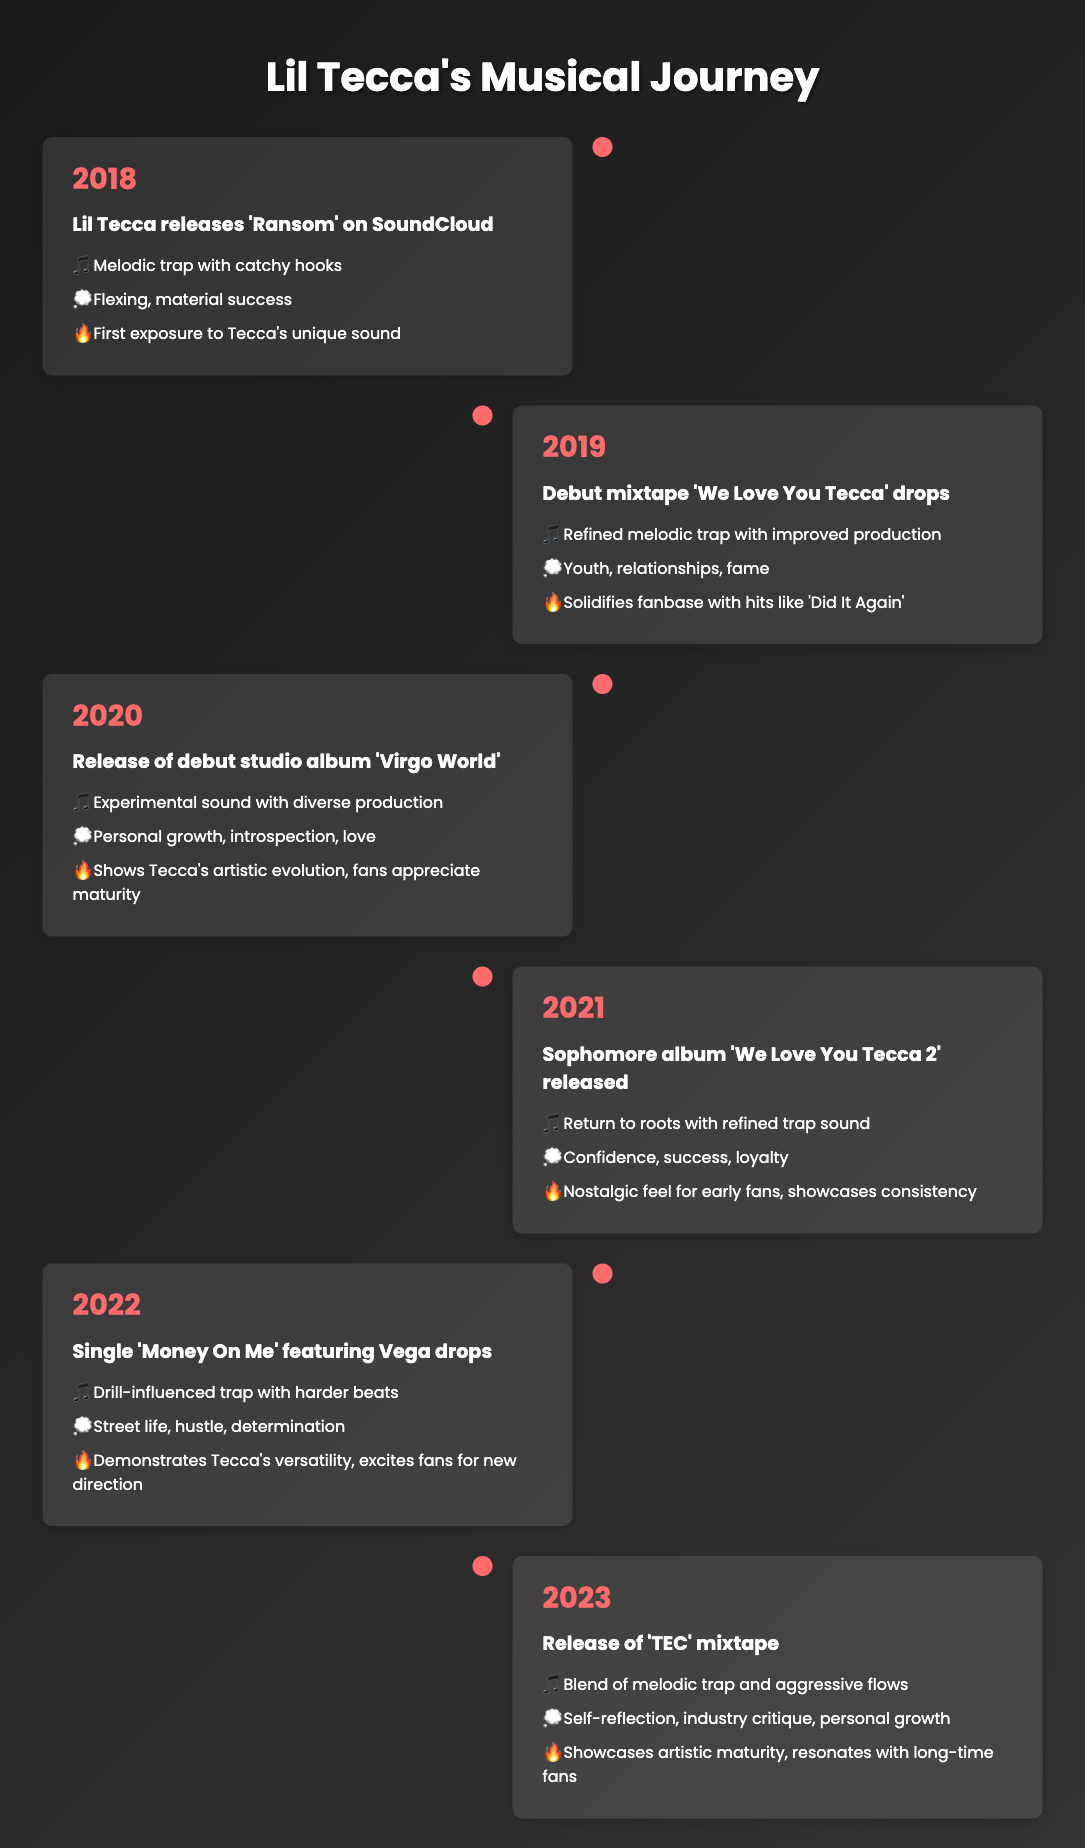What year did Lil Tecca release his debut mixtape? The table shows that Lil Tecca's debut mixtape 'We Love You Tecca' was released in 2019.
Answer: 2019 What themes are present in the song 'Ransom'? According to the table, the themes associated with 'Ransom' are flexing and material success, which were part of the event in 2018 when the song was released.
Answer: Flexing, material success Which album marks Lil Tecca's transition towards personal growth in his themes? The table indicates that the debut studio album 'Virgo World', released in 2020, includes themes of personal growth, introspection, and love, marking this transition.
Answer: 'Virgo World' How many events mentioned in the table reflect a change in musical style towards a harder sound? The table lists two events with harder sound styles: the 2022 single 'Money On Me' and the 2023 'TEC' mixtape, totaling two events.
Answer: 2 Is the statement "Lil Tecca's music style remained the same throughout his career" true? The table shows various shifts in musical style across the years, from melodic trap to experimental sounds and then to drill-influenced trap, making the statement false.
Answer: No Which two themes were present in both 'We Love You Tecca' and 'We Love You Tecca 2'? The table lists the themes for 'We Love You Tecca' as youth, relationships, and fame (2019) and for 'We Love You Tecca 2' as confidence, success, and loyalty (2021). The common theme is confidence related to success but there is no direct overlap, leading to an absence of common themes.
Answer: None In what way did fans respond to 'TEC' in comparison to earlier works? The table describes fans' response to 'TEC' as showcasing artistic maturity, resonating with long-time fans, which contrasts with earlier works that focused more on flexing and material success; this suggests a more profound appreciation for growth.
Answer: Fans appreciated growth What musical styles can be identified in Lil Tecca's releases from 2018 to 2023? The timeline reveals a variety of styles including melodic trap in 2018, refined melodic trap in 2019, experimental sound in 2020, refined trap in 2021, drill-influenced trap in 2022, and a blend of melodic trap with aggressive flows in 2023, showcasing significant musical diversity.
Answer: Melodic trap, refined melodic trap, experimental sound, refined trap, drill-influenced trap, blend of melodic and aggressive flows How did the themes in Lil Tecca's music evolve from his first release to his latest mixtape? Analyzing the themes, they transitioned from flexing and material success in 'Ransom' to more introspective themes like self-reflection and industry critique in the 'TEC' mixtape, indicating growth from superficial to more complex subjects.
Answer: Evolved from superficial to complex themes 